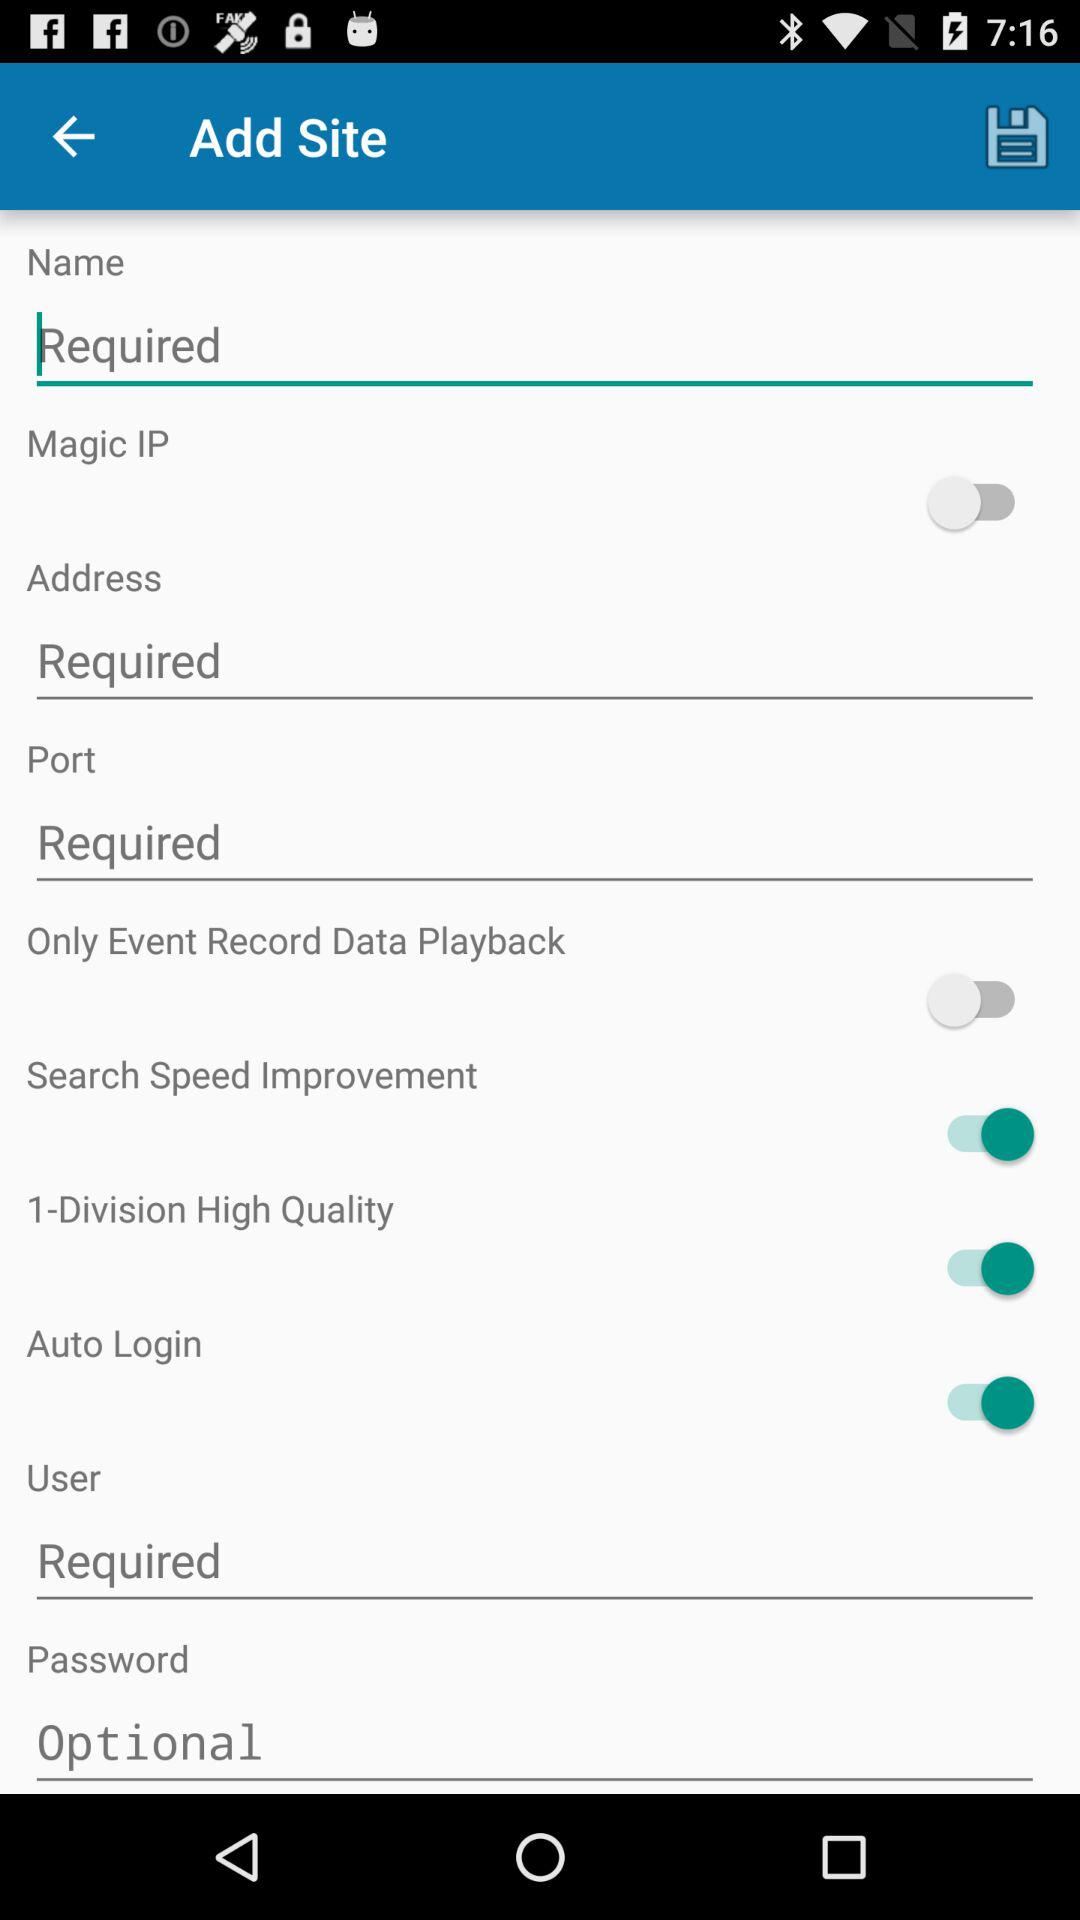What is the status of the "Auto Login"? The status is "on". 